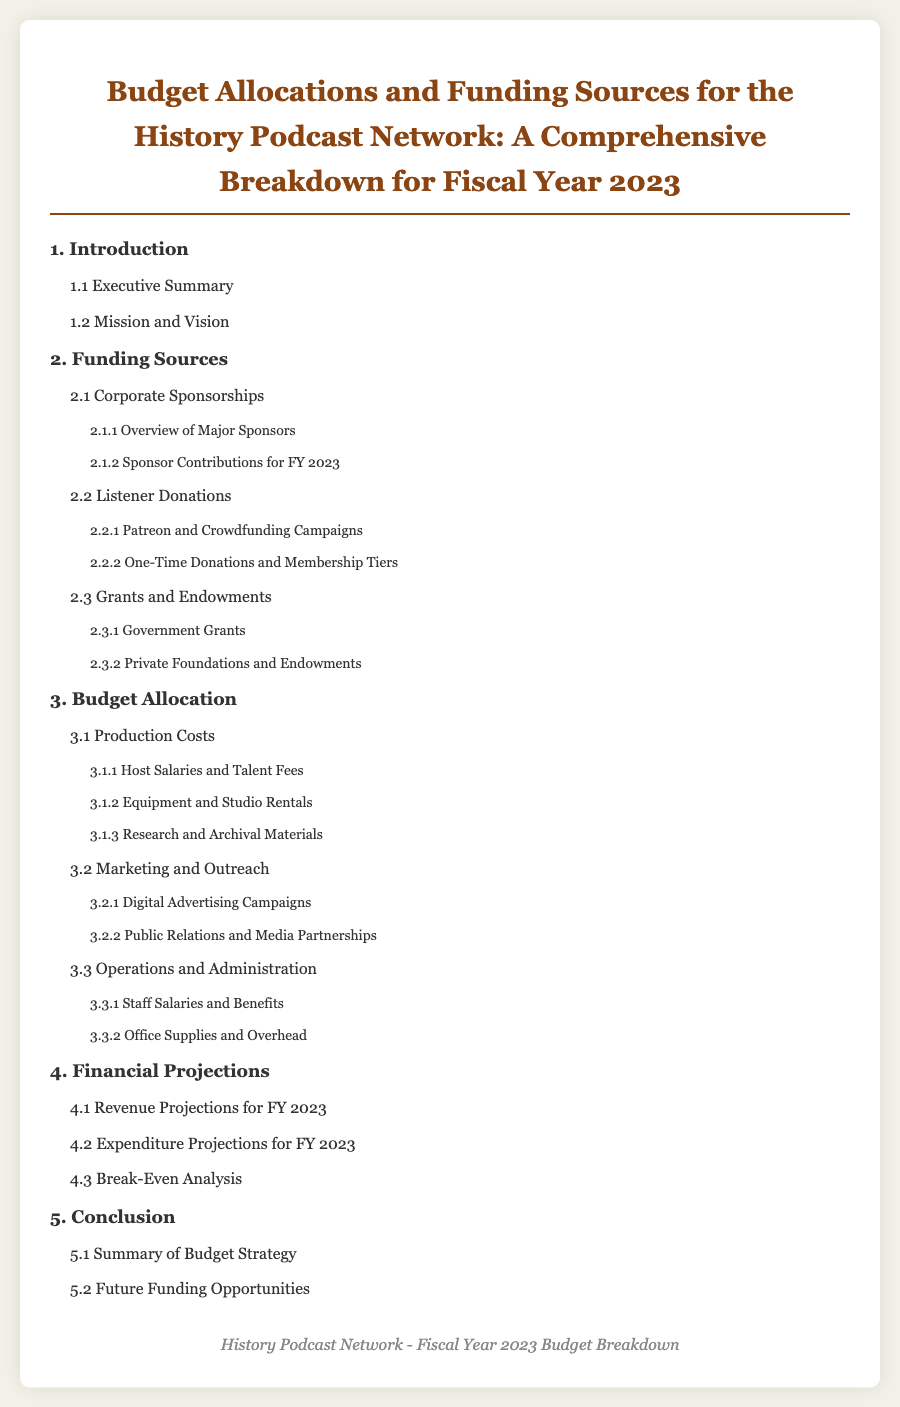What is the title of the document? The title is explicitly stated in the heading of the document.
Answer: Budget Allocations and Funding Sources for the History Podcast Network: A Comprehensive Breakdown for Fiscal Year 2023 What is the first section of the table of contents? The first section listed in the table of contents outlines what is included in the document.
Answer: Introduction What percentage of the budget is allocated to production costs? The percentage would need to be inferred from the allocation sections in the document.
Answer: Not specified Who is primarily responsible for the funding through corporate sponsorships? Corporate sponsorships consist of contributions from businesses that partner with the podcast.
Answer: Major sponsors What is one type of listener donation mentioned? This type of donation is specified as a formal method for fans to support the podcast.
Answer: Patreon and Crowdfunding Campaigns What section comes after "Budget Allocation"? The sections are ordered in a specific sequence, leading to what comes next.
Answer: Financial Projections How many subsections are listed under Funding Sources? The number includes all subsections that provide details under the Funding Sources section.
Answer: Six What primarily covers the operational costs? This section details various administrative fees related to running the podcast network.
Answer: Operations and Administration What is the final section of the document? The last section summarizes concepts discussed throughout the document, serving as a conclusion.
Answer: Conclusion 